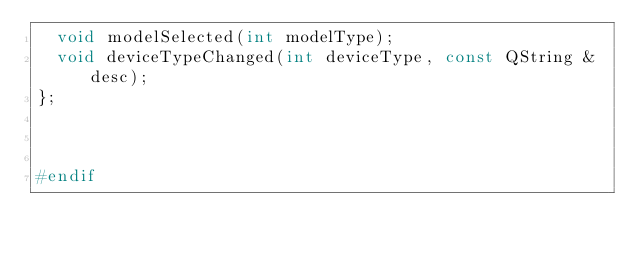<code> <loc_0><loc_0><loc_500><loc_500><_C_>  void modelSelected(int modelType);
  void deviceTypeChanged(int deviceType, const QString &desc);
};



#endif
</code> 